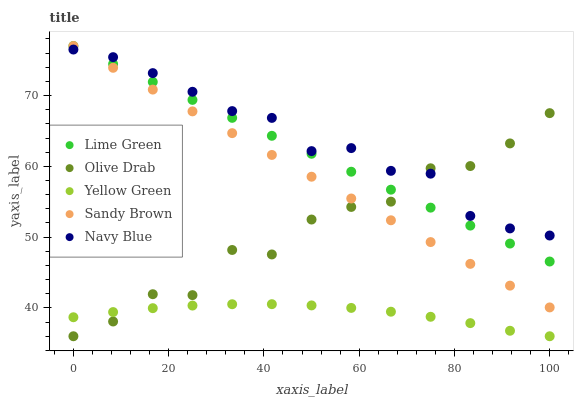Does Yellow Green have the minimum area under the curve?
Answer yes or no. Yes. Does Navy Blue have the maximum area under the curve?
Answer yes or no. Yes. Does Lime Green have the minimum area under the curve?
Answer yes or no. No. Does Lime Green have the maximum area under the curve?
Answer yes or no. No. Is Lime Green the smoothest?
Answer yes or no. Yes. Is Olive Drab the roughest?
Answer yes or no. Yes. Is Yellow Green the smoothest?
Answer yes or no. No. Is Yellow Green the roughest?
Answer yes or no. No. Does Yellow Green have the lowest value?
Answer yes or no. Yes. Does Lime Green have the lowest value?
Answer yes or no. No. Does Lime Green have the highest value?
Answer yes or no. Yes. Does Yellow Green have the highest value?
Answer yes or no. No. Is Yellow Green less than Navy Blue?
Answer yes or no. Yes. Is Navy Blue greater than Yellow Green?
Answer yes or no. Yes. Does Navy Blue intersect Olive Drab?
Answer yes or no. Yes. Is Navy Blue less than Olive Drab?
Answer yes or no. No. Is Navy Blue greater than Olive Drab?
Answer yes or no. No. Does Yellow Green intersect Navy Blue?
Answer yes or no. No. 